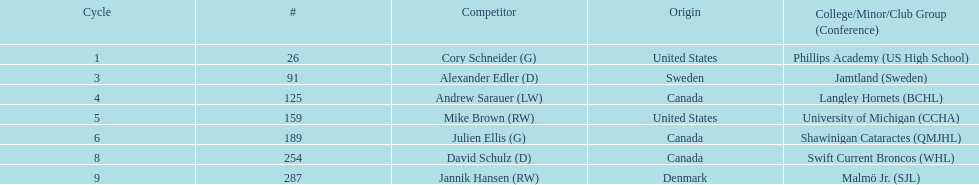How many players are from the united states? 2. 